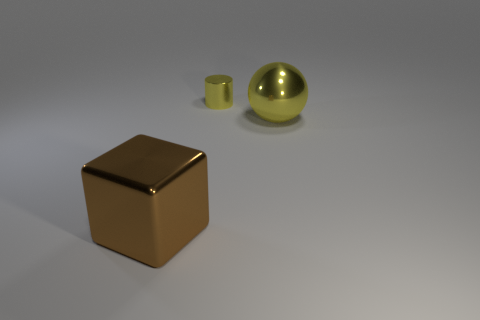There is a thing that is the same color as the big shiny sphere; what is it made of?
Provide a short and direct response. Metal. What is the shape of the object that is both in front of the tiny yellow metal cylinder and behind the brown shiny thing?
Keep it short and to the point. Sphere. What material is the thing on the left side of the yellow shiny object behind the sphere?
Your answer should be very brief. Metal. Are there more big brown objects than tiny brown cylinders?
Make the answer very short. Yes. Is the shiny cylinder the same color as the large metallic ball?
Provide a succinct answer. Yes. What number of large purple cylinders are made of the same material as the block?
Provide a short and direct response. 0. How many things are either big objects on the right side of the yellow cylinder or large metal objects that are on the right side of the large brown thing?
Ensure brevity in your answer.  1. Are there more small shiny objects behind the big brown metallic thing than metal cylinders that are on the left side of the yellow shiny cylinder?
Give a very brief answer. Yes. What is the color of the large metal thing that is behind the large block?
Offer a very short reply. Yellow. How many brown objects are either blocks or metallic objects?
Give a very brief answer. 1. 